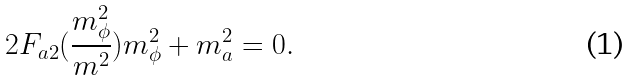<formula> <loc_0><loc_0><loc_500><loc_500>2 F _ { a 2 } ( { \frac { m _ { \phi } ^ { 2 } } { m ^ { 2 } } } ) m _ { \phi } ^ { 2 } + m _ { a } ^ { 2 } = 0 .</formula> 